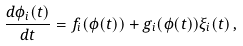Convert formula to latex. <formula><loc_0><loc_0><loc_500><loc_500>\frac { d \phi _ { i } ( t ) } { d t } = f _ { i } ( \phi ( t ) ) + g _ { i } ( \phi ( t ) ) \xi _ { i } ( t ) \, ,</formula> 